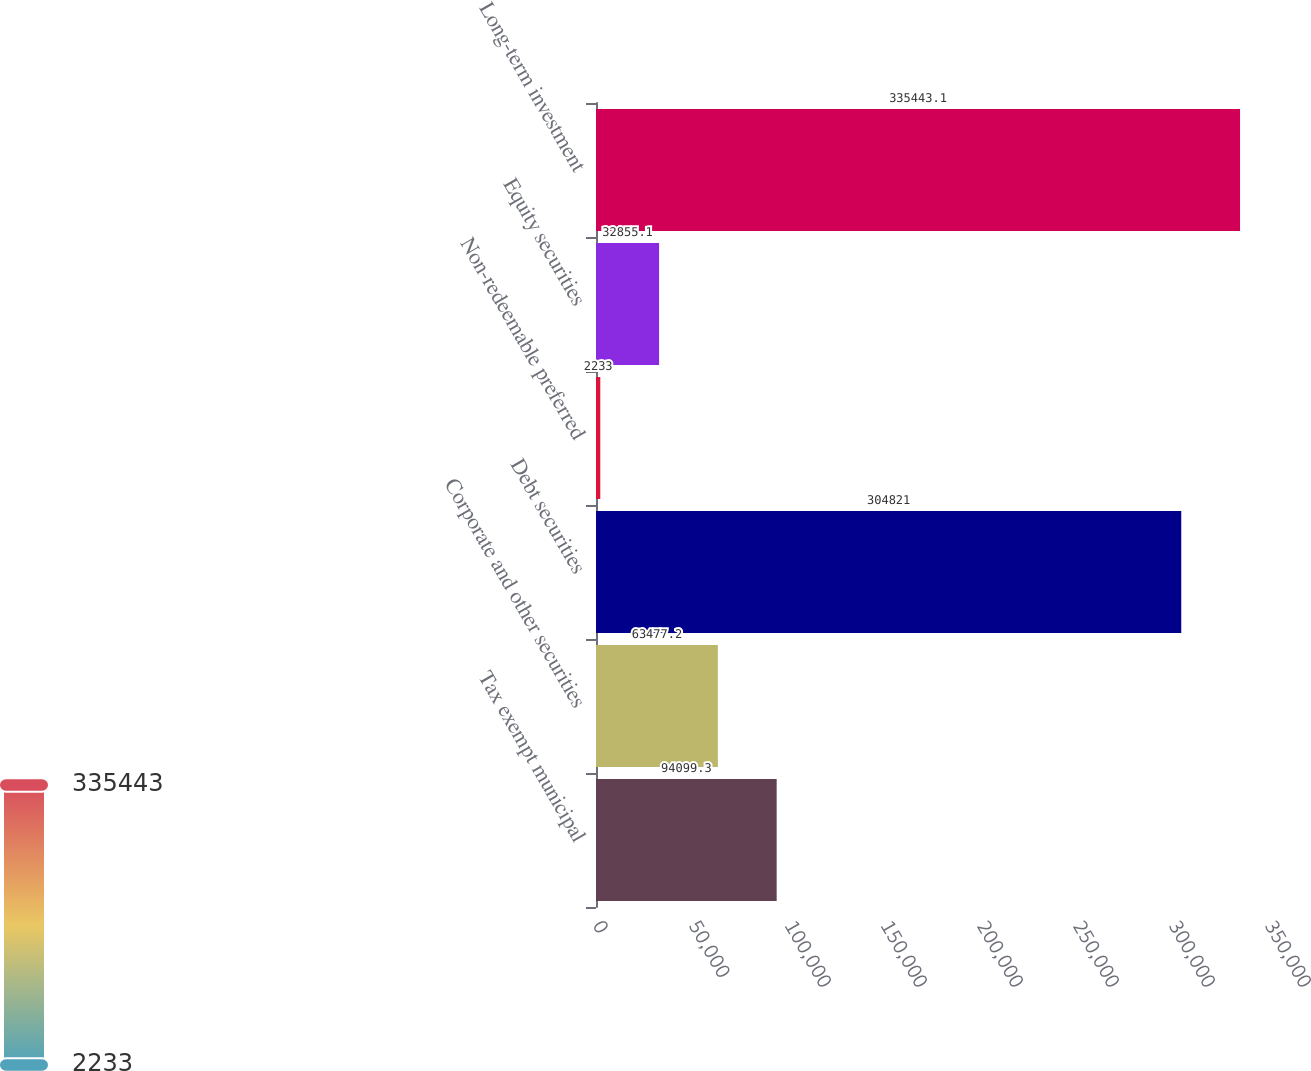<chart> <loc_0><loc_0><loc_500><loc_500><bar_chart><fcel>Tax exempt municipal<fcel>Corporate and other securities<fcel>Debt securities<fcel>Non-redeemable preferred<fcel>Equity securities<fcel>Long-term investment<nl><fcel>94099.3<fcel>63477.2<fcel>304821<fcel>2233<fcel>32855.1<fcel>335443<nl></chart> 